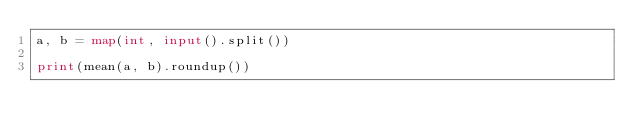Convert code to text. <code><loc_0><loc_0><loc_500><loc_500><_Python_>a, b = map(int, input().split())

print(mean(a, b).roundup())</code> 